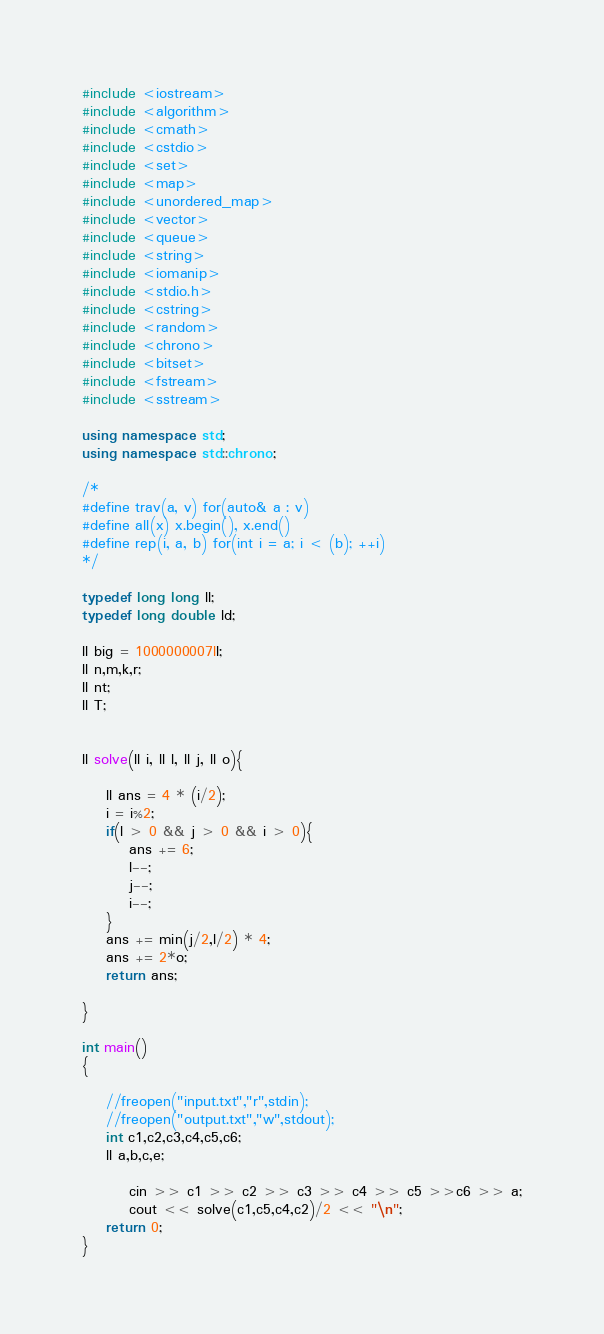Convert code to text. <code><loc_0><loc_0><loc_500><loc_500><_C++_>#include <iostream>
#include <algorithm>
#include <cmath>
#include <cstdio>
#include <set>
#include <map>
#include <unordered_map>
#include <vector>
#include <queue>
#include <string>
#include <iomanip>
#include <stdio.h>
#include <cstring>
#include <random>
#include <chrono>
#include <bitset>
#include <fstream>
#include <sstream>

using namespace std;
using namespace std::chrono;

/*
#define trav(a, v) for(auto& a : v)
#define all(x) x.begin(), x.end()
#define rep(i, a, b) for(int i = a; i < (b); ++i)
*/

typedef long long ll;
typedef long double ld;

ll big = 1000000007ll;
ll n,m,k,r;
ll nt;
ll T;


ll solve(ll i, ll l, ll j, ll o){

    ll ans = 4 * (i/2);
    i = i%2;
    if(l > 0 && j > 0 && i > 0){
        ans += 6;
        l--;
        j--;
        i--;
    }
    ans += min(j/2,l/2) * 4;
    ans += 2*o;
    return ans;

}

int main()
{

    //freopen("input.txt","r",stdin);
    //freopen("output.txt","w",stdout);
    int c1,c2,c3,c4,c5,c6;
    ll a,b,c,e;

        cin >> c1 >> c2 >> c3 >> c4 >> c5 >>c6 >> a;
        cout << solve(c1,c5,c4,c2)/2 << "\n";
    return 0;
}
</code> 